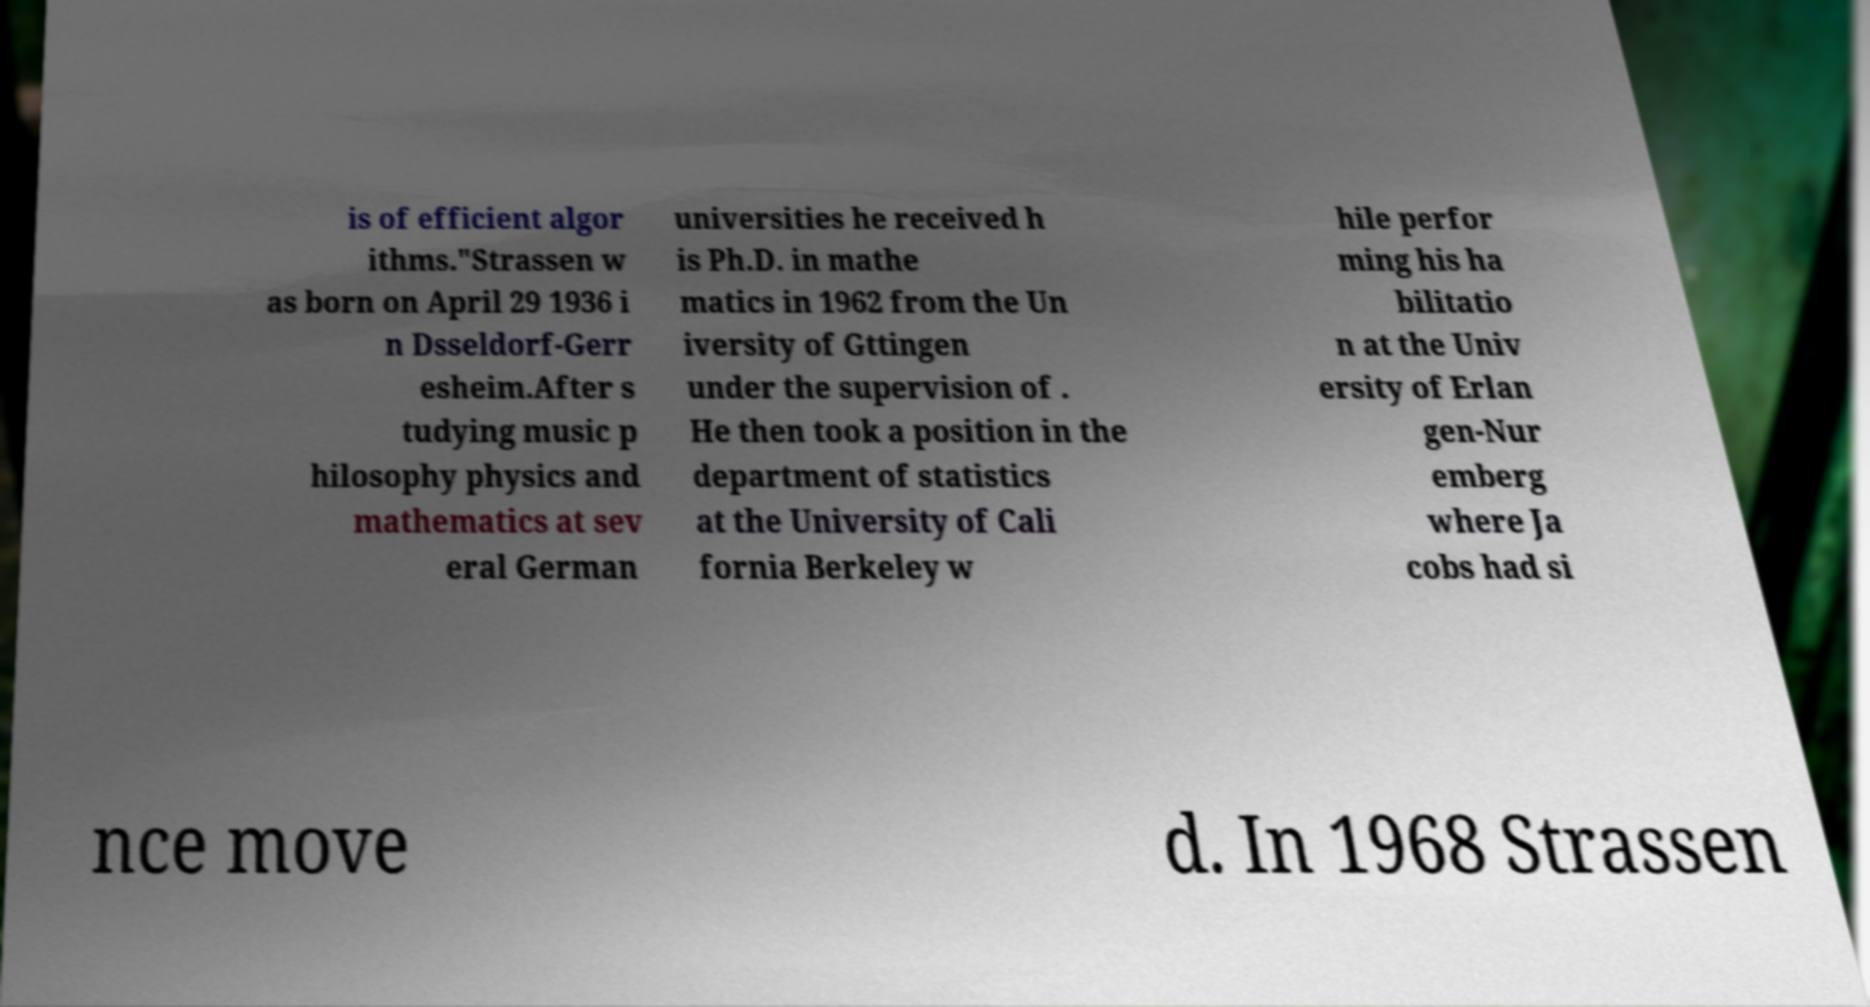Can you accurately transcribe the text from the provided image for me? is of efficient algor ithms."Strassen w as born on April 29 1936 i n Dsseldorf-Gerr esheim.After s tudying music p hilosophy physics and mathematics at sev eral German universities he received h is Ph.D. in mathe matics in 1962 from the Un iversity of Gttingen under the supervision of . He then took a position in the department of statistics at the University of Cali fornia Berkeley w hile perfor ming his ha bilitatio n at the Univ ersity of Erlan gen-Nur emberg where Ja cobs had si nce move d. In 1968 Strassen 